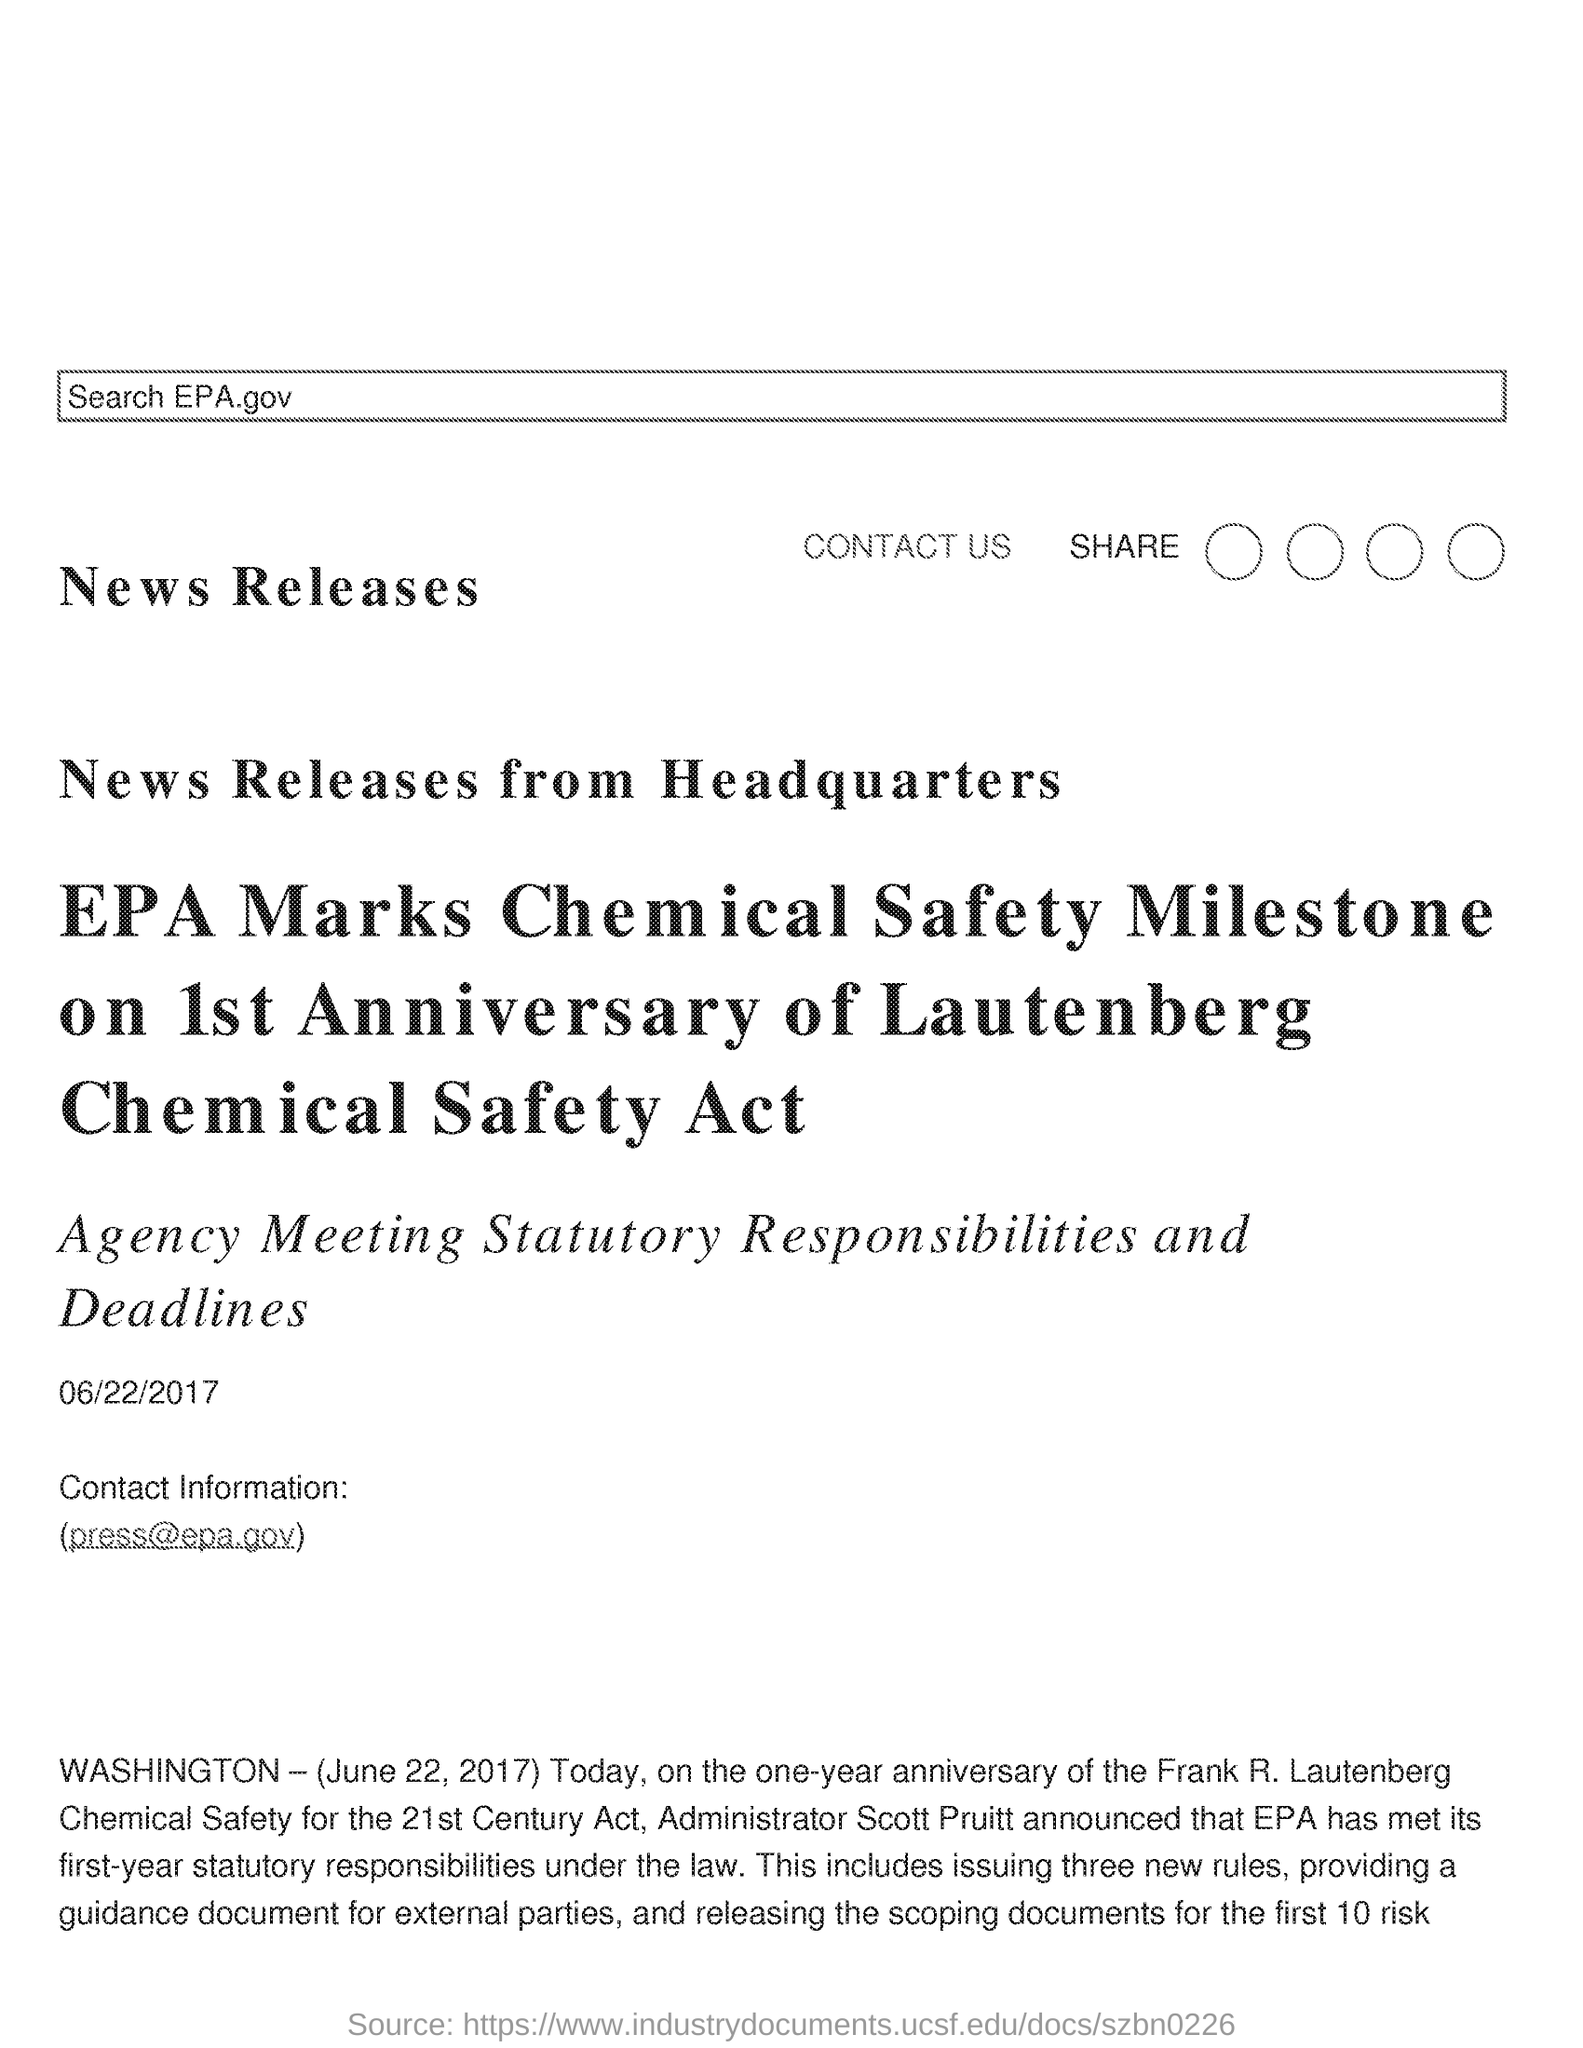Identify some key points in this picture. The contact information provided in the document is "[press@epa.gov](mailto:press@epa.gov) The date mentioned in the document is 06/22/2017. 